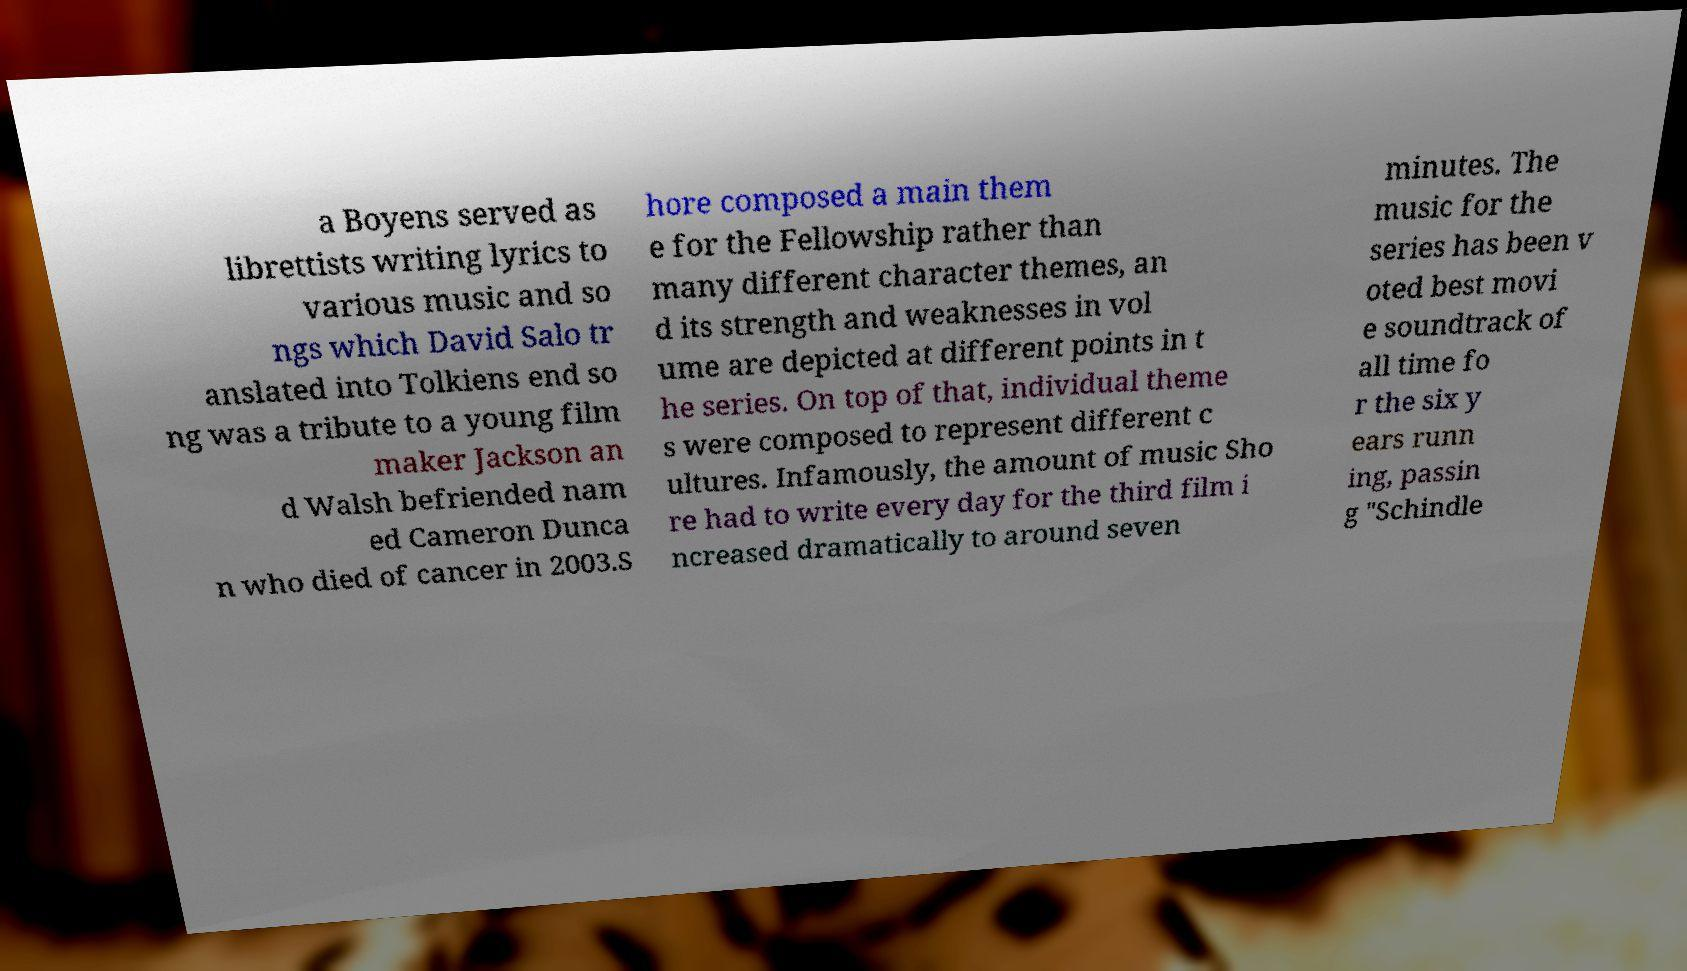Can you accurately transcribe the text from the provided image for me? a Boyens served as librettists writing lyrics to various music and so ngs which David Salo tr anslated into Tolkiens end so ng was a tribute to a young film maker Jackson an d Walsh befriended nam ed Cameron Dunca n who died of cancer in 2003.S hore composed a main them e for the Fellowship rather than many different character themes, an d its strength and weaknesses in vol ume are depicted at different points in t he series. On top of that, individual theme s were composed to represent different c ultures. Infamously, the amount of music Sho re had to write every day for the third film i ncreased dramatically to around seven minutes. The music for the series has been v oted best movi e soundtrack of all time fo r the six y ears runn ing, passin g "Schindle 